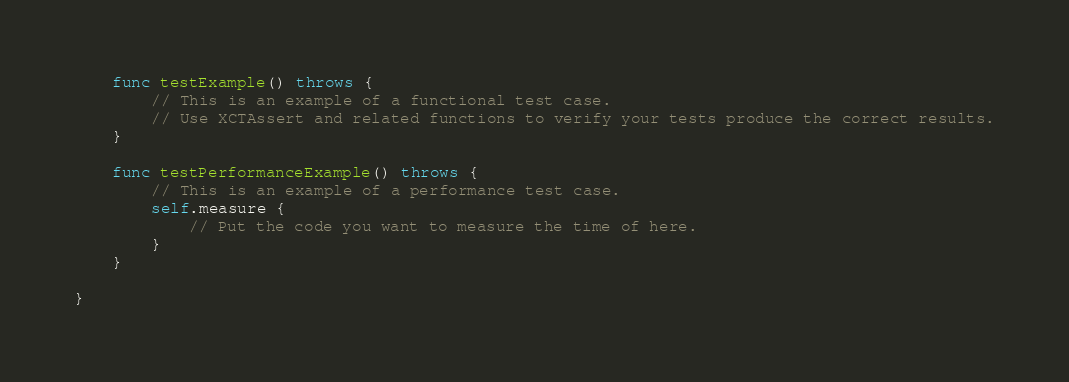<code> <loc_0><loc_0><loc_500><loc_500><_Swift_>
    func testExample() throws {
        // This is an example of a functional test case.
        // Use XCTAssert and related functions to verify your tests produce the correct results.
    }

    func testPerformanceExample() throws {
        // This is an example of a performance test case.
        self.measure {
            // Put the code you want to measure the time of here.
        }
    }

}
</code> 